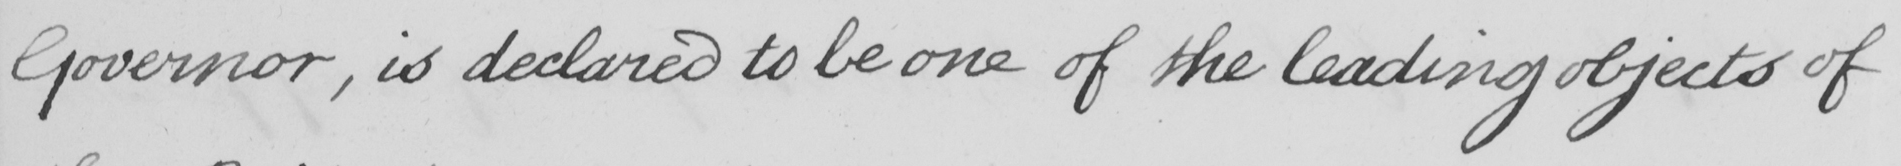What is written in this line of handwriting? Governor , is declared to be one of the leading objects of 